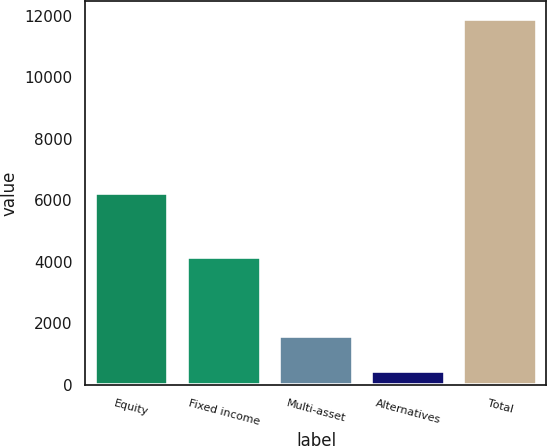Convert chart to OTSL. <chart><loc_0><loc_0><loc_500><loc_500><bar_chart><fcel>Equity<fcel>Fixed income<fcel>Multi-asset<fcel>Alternatives<fcel>Total<nl><fcel>6254<fcel>4157<fcel>1589.9<fcel>446<fcel>11885<nl></chart> 